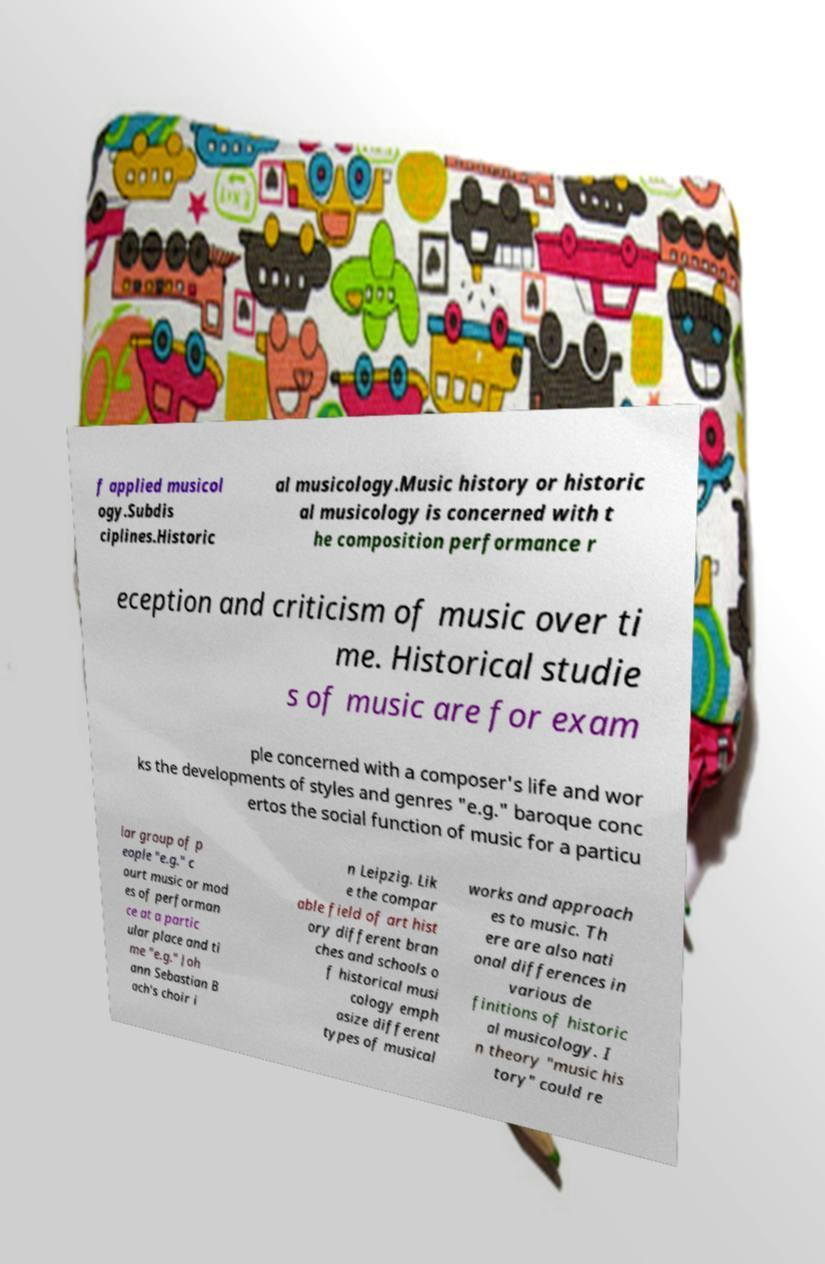What messages or text are displayed in this image? I need them in a readable, typed format. f applied musicol ogy.Subdis ciplines.Historic al musicology.Music history or historic al musicology is concerned with t he composition performance r eception and criticism of music over ti me. Historical studie s of music are for exam ple concerned with a composer's life and wor ks the developments of styles and genres "e.g." baroque conc ertos the social function of music for a particu lar group of p eople "e.g." c ourt music or mod es of performan ce at a partic ular place and ti me "e.g." Joh ann Sebastian B ach's choir i n Leipzig. Lik e the compar able field of art hist ory different bran ches and schools o f historical musi cology emph asize different types of musical works and approach es to music. Th ere are also nati onal differences in various de finitions of historic al musicology. I n theory "music his tory" could re 